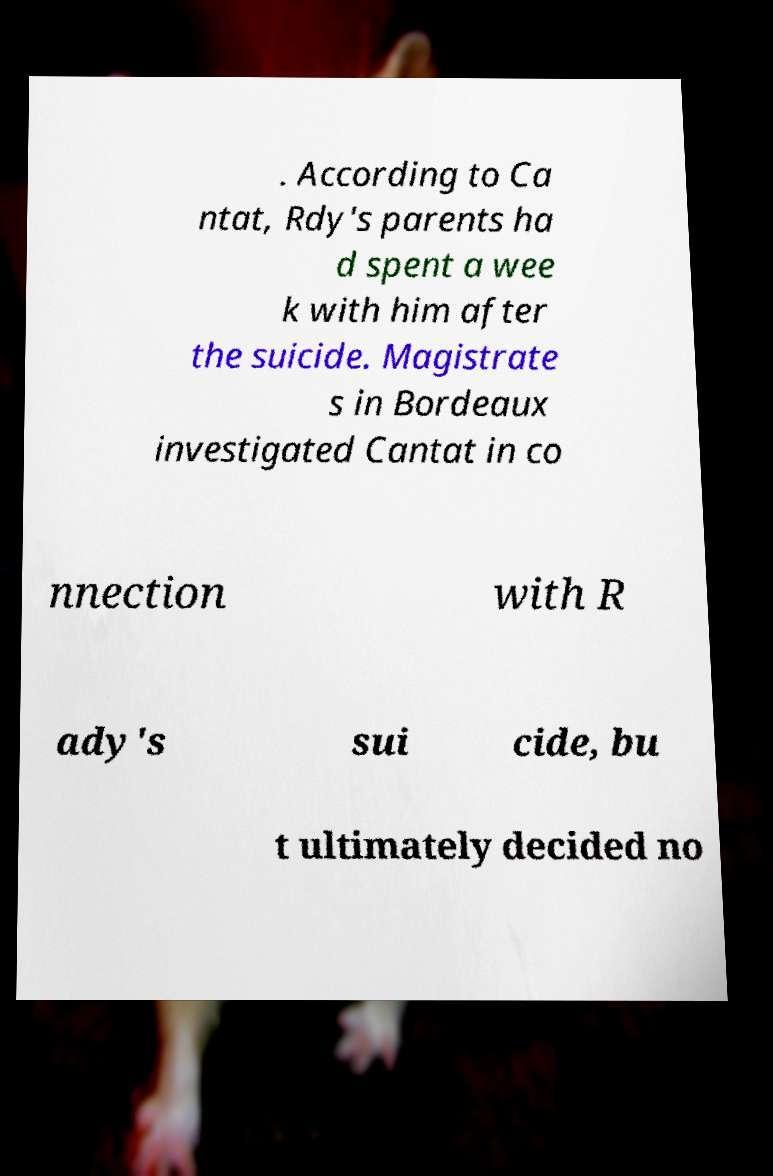I need the written content from this picture converted into text. Can you do that? . According to Ca ntat, Rdy's parents ha d spent a wee k with him after the suicide. Magistrate s in Bordeaux investigated Cantat in co nnection with R ady's sui cide, bu t ultimately decided no 